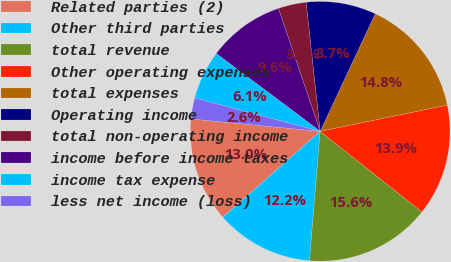Convert chart to OTSL. <chart><loc_0><loc_0><loc_500><loc_500><pie_chart><fcel>Related parties (2)<fcel>Other third parties<fcel>total revenue<fcel>Other operating expenses<fcel>total expenses<fcel>Operating income<fcel>total non-operating income<fcel>income before income taxes<fcel>income tax expense<fcel>less net income (loss)<nl><fcel>13.04%<fcel>12.17%<fcel>15.65%<fcel>13.91%<fcel>14.78%<fcel>8.7%<fcel>3.48%<fcel>9.57%<fcel>6.09%<fcel>2.61%<nl></chart> 